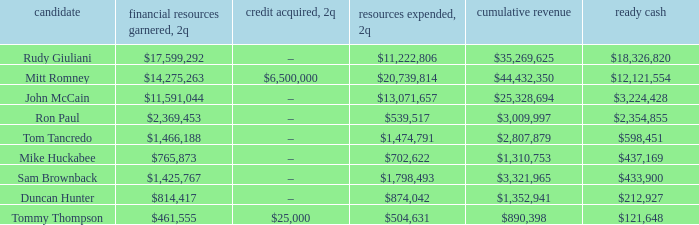Name the money spent for 2Q having candidate of john mccain $13,071,657. 